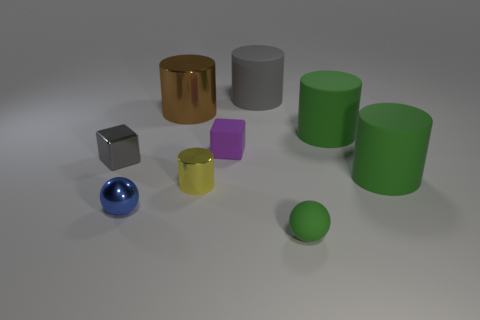How many objects have the same color as the tiny rubber sphere?
Offer a terse response. 2. Are there fewer green objects than yellow metal cubes?
Your answer should be very brief. No. Are the large cylinder on the left side of the rubber cube and the green sphere that is in front of the big brown cylinder made of the same material?
Provide a short and direct response. No. What shape is the large thing to the left of the tiny rubber object to the left of the rubber object in front of the tiny blue sphere?
Keep it short and to the point. Cylinder. What number of large green objects have the same material as the green sphere?
Make the answer very short. 2. There is a large matte cylinder that is in front of the purple matte cube; how many large rubber cylinders are to the right of it?
Provide a short and direct response. 0. Does the big cylinder in front of the gray metal cube have the same color as the tiny thing in front of the blue thing?
Make the answer very short. Yes. There is a large thing that is behind the gray block and in front of the big brown object; what is its shape?
Your answer should be compact. Cylinder. Are there any small red matte things of the same shape as the yellow shiny thing?
Provide a succinct answer. No. The gray metal object that is the same size as the shiny ball is what shape?
Your response must be concise. Cube. 